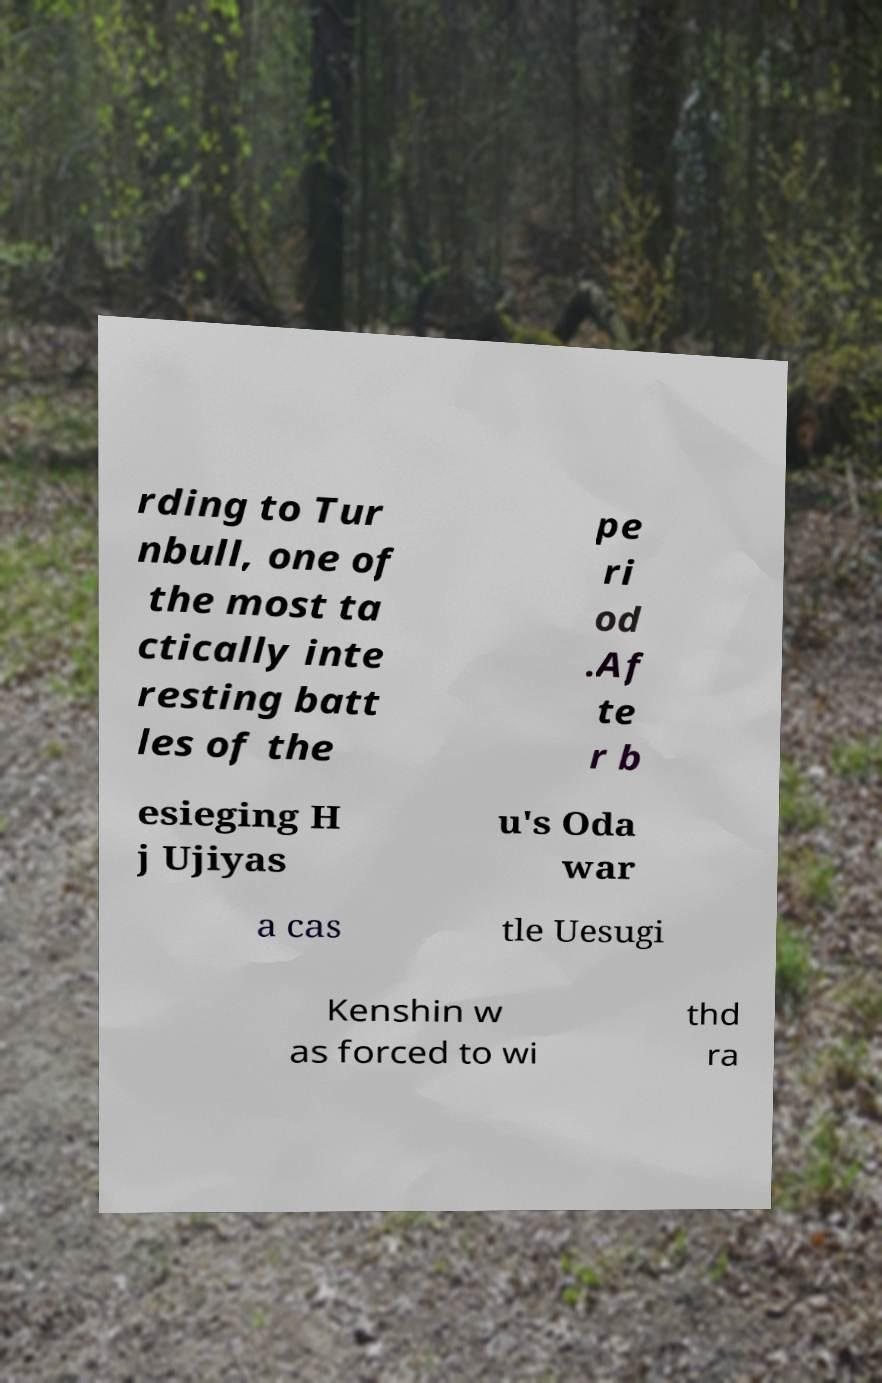Can you accurately transcribe the text from the provided image for me? rding to Tur nbull, one of the most ta ctically inte resting batt les of the pe ri od .Af te r b esieging H j Ujiyas u's Oda war a cas tle Uesugi Kenshin w as forced to wi thd ra 